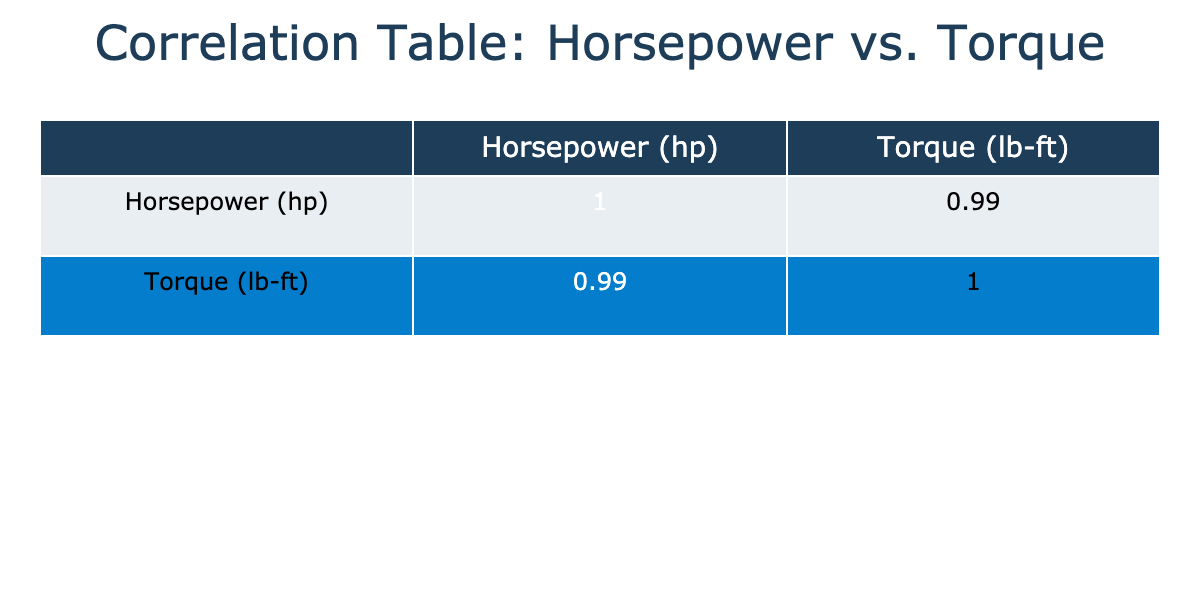What is the horsepower output of the turbocharger modification? The table shows that the turbocharger modification for the Inline-6 engine has a horsepower output of 400 hp.
Answer: 400 hp What is the torque output of the supercharger modification? By looking at the table, the supercharger modification has a torque output of 425 lb-ft for the Inline-6 engine.
Answer: 425 lb-ft Is the horsepower output of the nitrous oxide system greater than that of the performance exhaust? The table indicates that the nitrous oxide system has a horsepower output of 500 hp, while the performance exhaust has an output of 275 hp. Since 500 is greater than 275, the answer is yes.
Answer: Yes What is the difference in torque output between the highest and lowest horsepower modifications? The highest horsepower modification is the nitrous oxide system with 500 hp and the lowest is the cold air intake with 265 hp. The corresponding torque outputs are 520 lb-ft and 280 lb-ft. The differences in torque output are 520 - 280 = 240 lb-ft.
Answer: 240 lb-ft What is the average horsepower output for V8 engine modifications? The V8 modifications have horsepower outputs of 350, 375, 360, and 380 hp. Adding these together gives 350 + 375 + 360 + 380 = 1465 hp. There are 4 data points, so dividing by 4 gives an average of 1465 / 4 = 366.25 hp, which can be rounded to 366 hp.
Answer: 366 hp Does any modification result in a torque output over 500 lb-ft? The table indicates that the nitrous oxide system reaches a torque output of 520 lb-ft, which is greater than 500. Hence, there is at least one modification with a torque output over 500 lb-ft.
Answer: Yes Which modification provides the highest torque output among the modifications listed? The nitrous oxide system reports a torque output of 520 lb-ft, while all other improvement modifications have lower torque values. Thus, it provides the highest torque output.
Answer: Nitrous Oxide System What is the total horsepower output of all the modifications listed? Summing up all the horsepower figures: 265 + 275 + 290 + 400 + 385 + 350 + 375 + 360 + 380 + 280 + 320 + 310 + 360 + 450 + 500 = 4630 hp. Therefore, the total horsepower output of all modifications is 4630 hp.
Answer: 4630 hp Which engine type has the lowest average horsepower when considering its modifications? The modifications for the Inline-6 engine have horsepower outputs of 265, 275, 290, 400, and 385. Adding these gives 265 + 275 + 290 + 400 + 385 = 1615 hp. With 5 data points, the average is 1615 / 5 = 323 hp. The V8 engine modifications have a higher average, so it's concluded that the Inline-6 has the lowest average horsepower.
Answer: Inline-6 